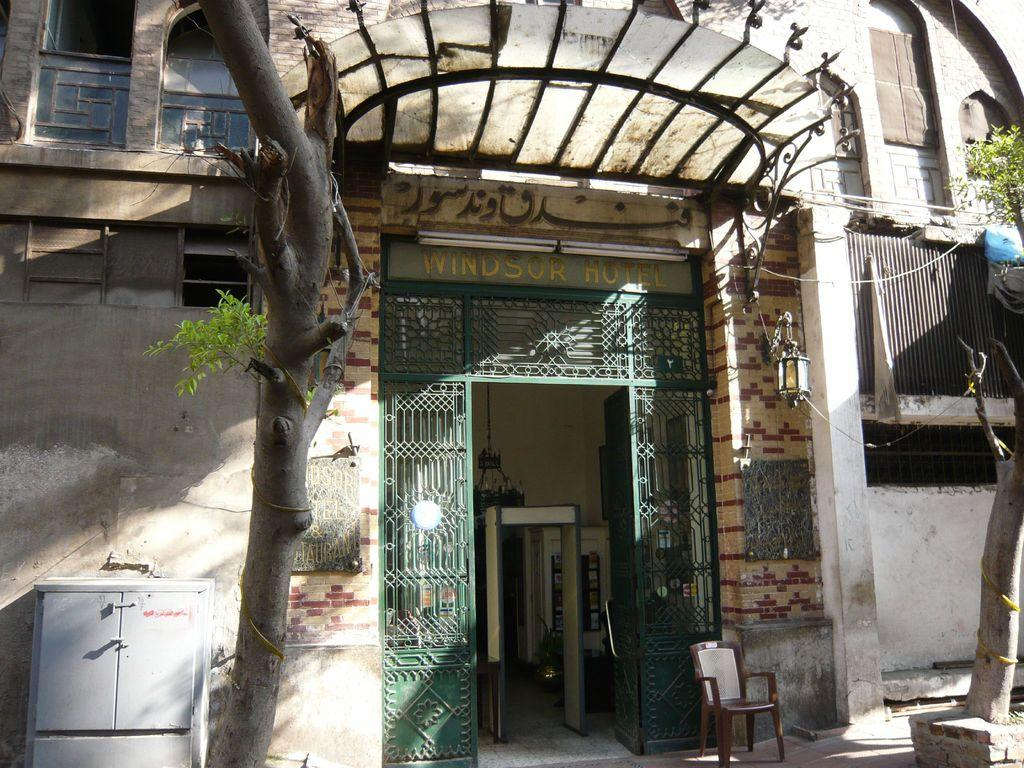Provide a one-sentence caption for the provided image. The front of the Windsor Hotel street view. 